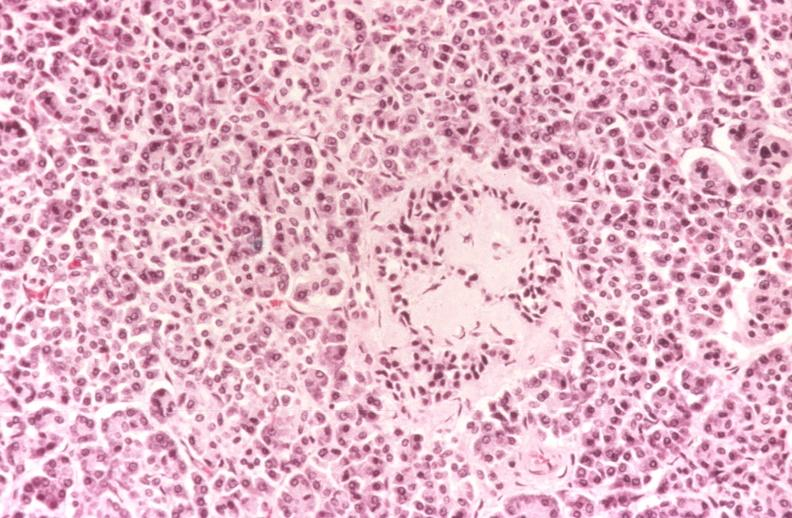s pancreas present?
Answer the question using a single word or phrase. Yes 